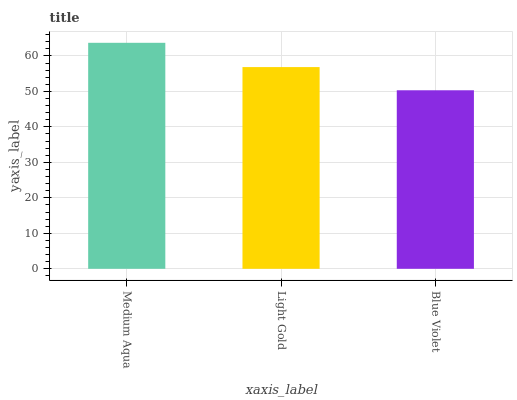Is Blue Violet the minimum?
Answer yes or no. Yes. Is Medium Aqua the maximum?
Answer yes or no. Yes. Is Light Gold the minimum?
Answer yes or no. No. Is Light Gold the maximum?
Answer yes or no. No. Is Medium Aqua greater than Light Gold?
Answer yes or no. Yes. Is Light Gold less than Medium Aqua?
Answer yes or no. Yes. Is Light Gold greater than Medium Aqua?
Answer yes or no. No. Is Medium Aqua less than Light Gold?
Answer yes or no. No. Is Light Gold the high median?
Answer yes or no. Yes. Is Light Gold the low median?
Answer yes or no. Yes. Is Medium Aqua the high median?
Answer yes or no. No. Is Blue Violet the low median?
Answer yes or no. No. 